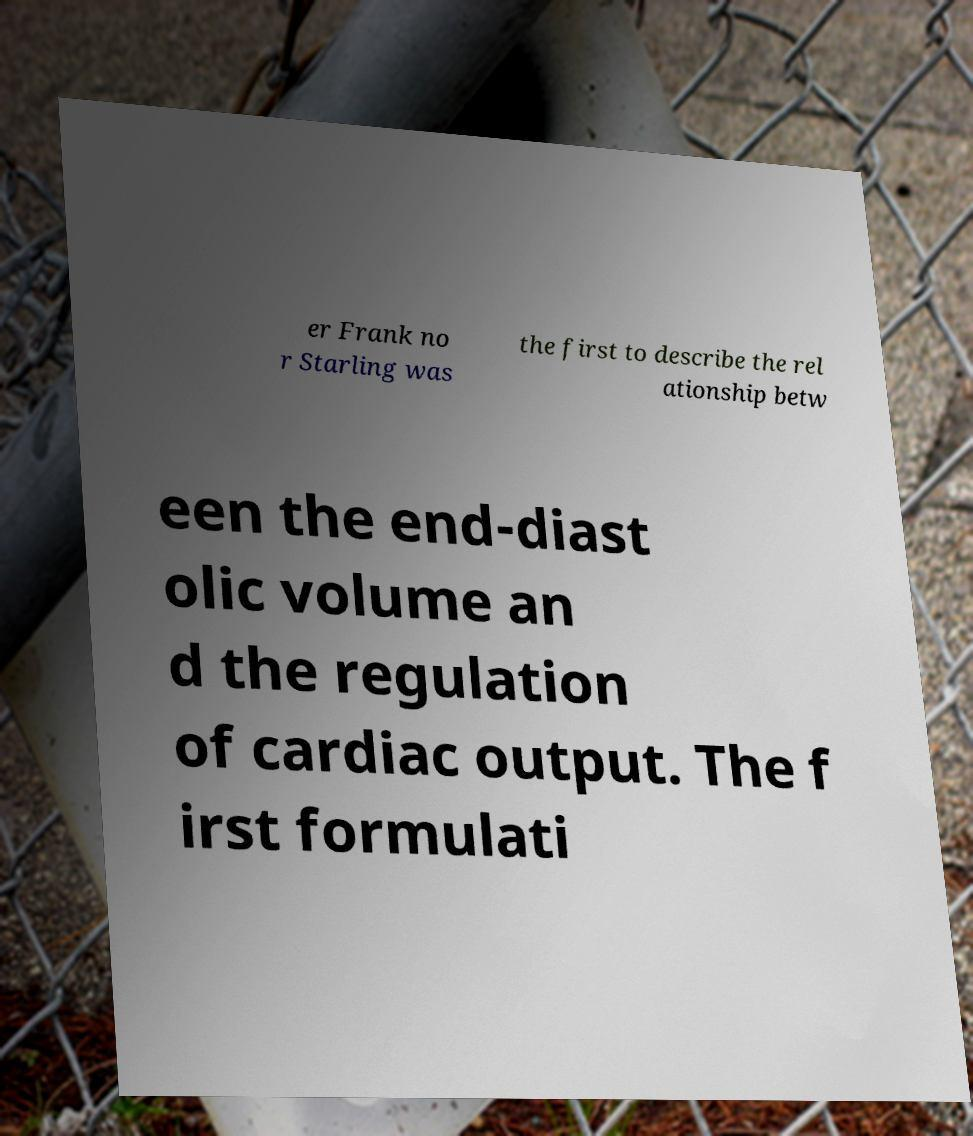I need the written content from this picture converted into text. Can you do that? er Frank no r Starling was the first to describe the rel ationship betw een the end-diast olic volume an d the regulation of cardiac output. The f irst formulati 